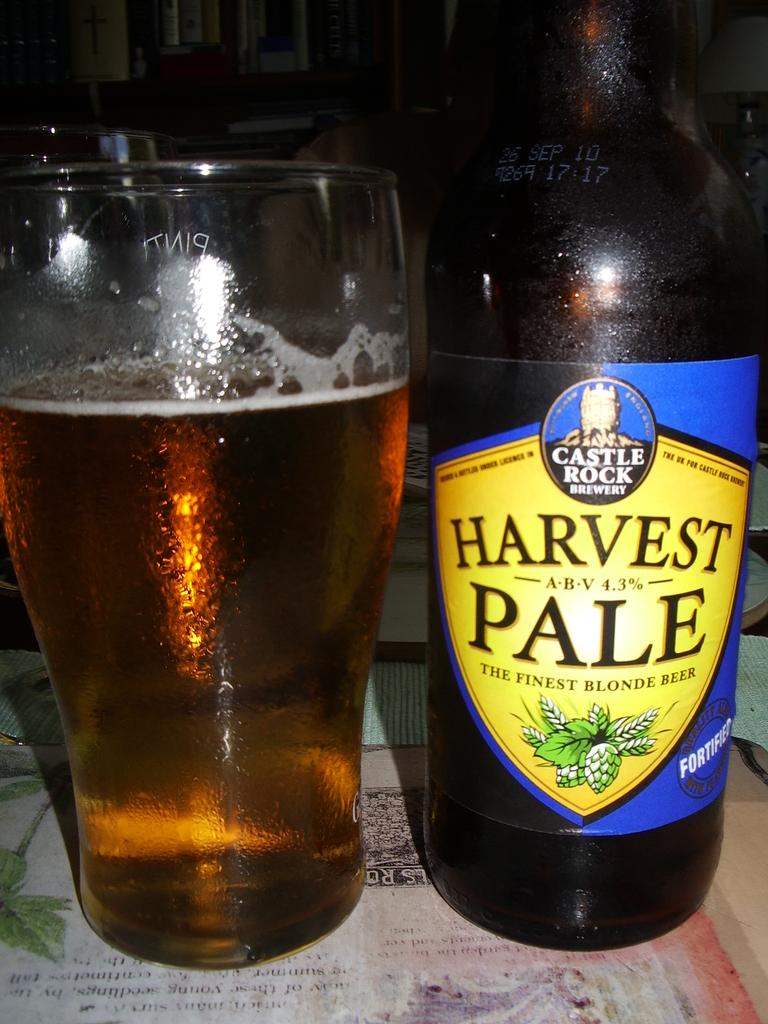What type of beverage is featured in the image? There is a beer bottle with a label and a glass of beer in the image. Where are the beer bottle and glass located? Both the beer bottle and glass are on a table. What can be observed about the background of the image? The background of the image is dark. What type of soap is being used to clean the man's regret in the image? There is no man, regret, or soap present in the image. 